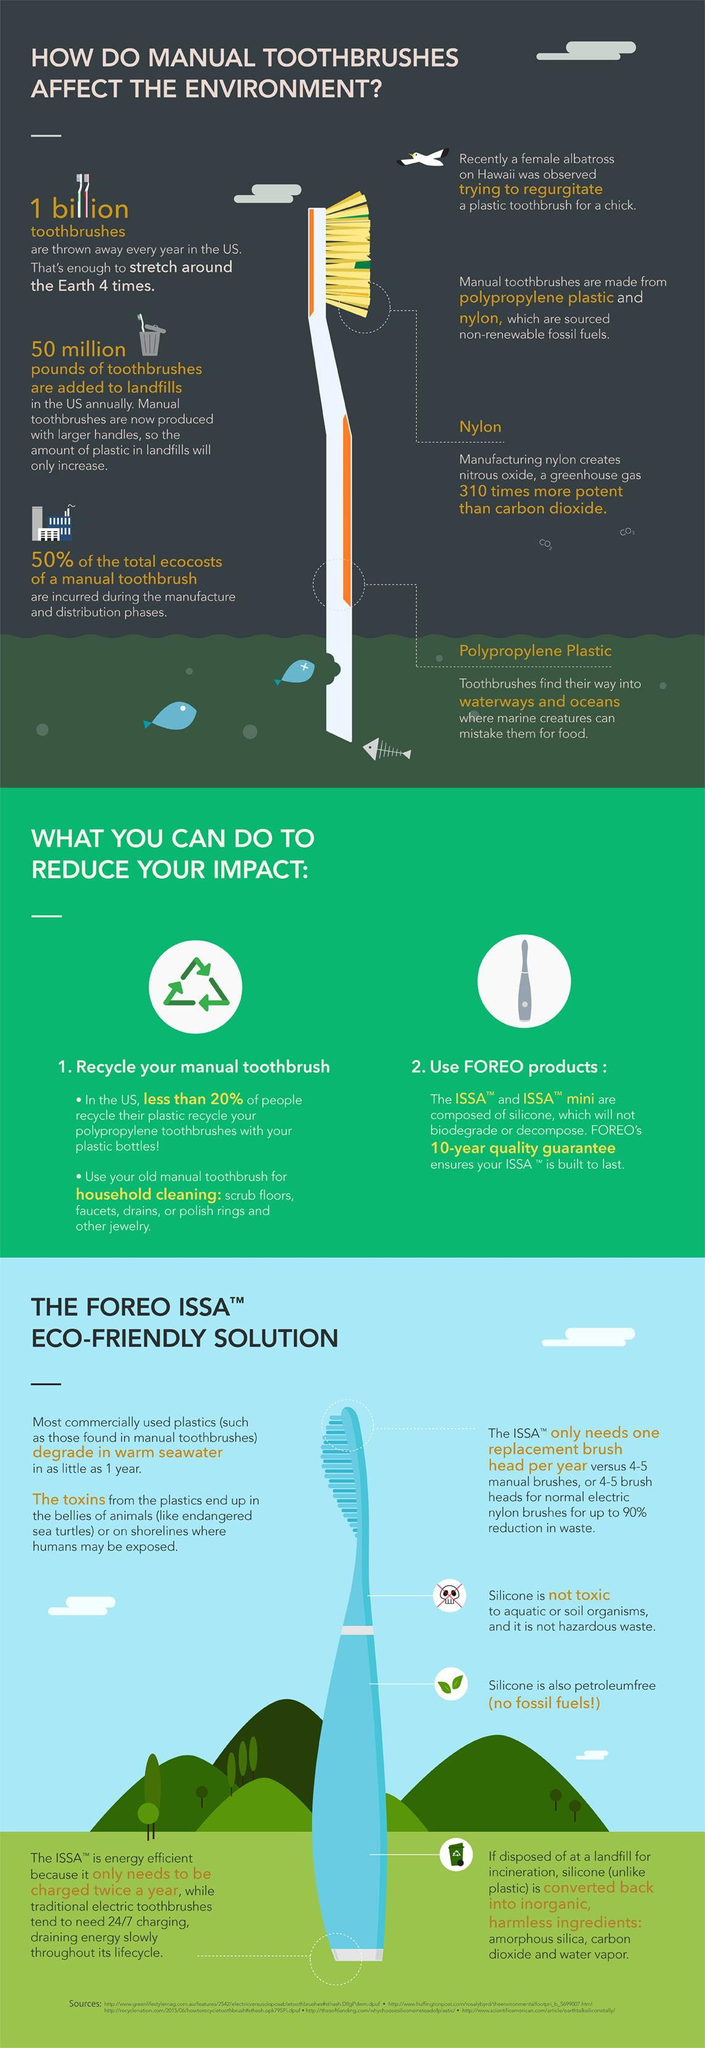Outline some significant characteristics in this image. Approximately 1 billion toothbrushes are discarded each year in the United States. The product that needs to be charged only twice a year is the ISSA. The silicone material is converted into amorphous silica, carbon dioxide, and water vapor upon proper disposal. The body of the manual toothbrush is made of polypropylene plastic. Warm sea water can degrade many commonly used plastics, posing a significant threat to marine life and the environment. 